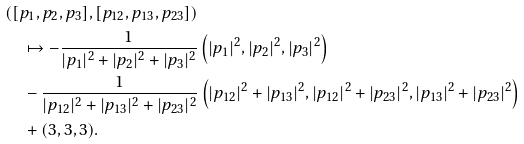Convert formula to latex. <formula><loc_0><loc_0><loc_500><loc_500>& ( [ p _ { 1 } , p _ { 2 } , p _ { 3 } ] , [ p _ { 1 2 } , p _ { 1 3 } , p _ { 2 3 } ] ) \\ & \quad \mapsto - \frac { 1 } { | p _ { 1 } | ^ { 2 } + | p _ { 2 } | ^ { 2 } + | p _ { 3 } | ^ { 2 } } \left ( { | p _ { 1 } | ^ { 2 } } , { | p _ { 2 } | ^ { 2 } } , { | p _ { 3 } | ^ { 2 } } \right ) \\ & \quad - \frac { 1 } { | p _ { 1 2 } | ^ { 2 } + | p _ { 1 3 } | ^ { 2 } + | p _ { 2 3 } | ^ { 2 } } \left ( { | p _ { 1 2 } | ^ { 2 } + | p _ { 1 3 } | ^ { 2 } } , { | p _ { 1 2 } | ^ { 2 } + | p _ { 2 3 } | ^ { 2 } } , { | p _ { 1 3 } | ^ { 2 } + | p _ { 2 3 } | ^ { 2 } } \right ) \\ & \quad + ( 3 , 3 , 3 ) .</formula> 